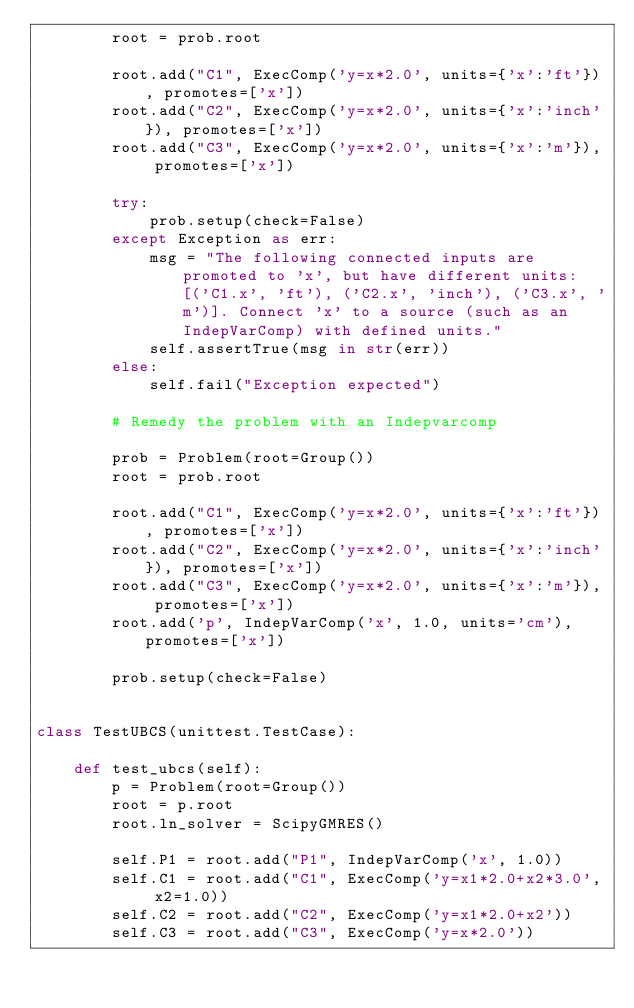<code> <loc_0><loc_0><loc_500><loc_500><_Python_>        root = prob.root

        root.add("C1", ExecComp('y=x*2.0', units={'x':'ft'}), promotes=['x'])
        root.add("C2", ExecComp('y=x*2.0', units={'x':'inch'}), promotes=['x'])
        root.add("C3", ExecComp('y=x*2.0', units={'x':'m'}), promotes=['x'])

        try:
            prob.setup(check=False)
        except Exception as err:
            msg = "The following connected inputs are promoted to 'x', but have different units: [('C1.x', 'ft'), ('C2.x', 'inch'), ('C3.x', 'm')]. Connect 'x' to a source (such as an IndepVarComp) with defined units."
            self.assertTrue(msg in str(err))
        else:
            self.fail("Exception expected")

        # Remedy the problem with an Indepvarcomp

        prob = Problem(root=Group())
        root = prob.root

        root.add("C1", ExecComp('y=x*2.0', units={'x':'ft'}), promotes=['x'])
        root.add("C2", ExecComp('y=x*2.0', units={'x':'inch'}), promotes=['x'])
        root.add("C3", ExecComp('y=x*2.0', units={'x':'m'}), promotes=['x'])
        root.add('p', IndepVarComp('x', 1.0, units='cm'), promotes=['x'])

        prob.setup(check=False)


class TestUBCS(unittest.TestCase):

    def test_ubcs(self):
        p = Problem(root=Group())
        root = p.root
        root.ln_solver = ScipyGMRES()

        self.P1 = root.add("P1", IndepVarComp('x', 1.0))
        self.C1 = root.add("C1", ExecComp('y=x1*2.0+x2*3.0', x2=1.0))
        self.C2 = root.add("C2", ExecComp('y=x1*2.0+x2'))
        self.C3 = root.add("C3", ExecComp('y=x*2.0'))</code> 